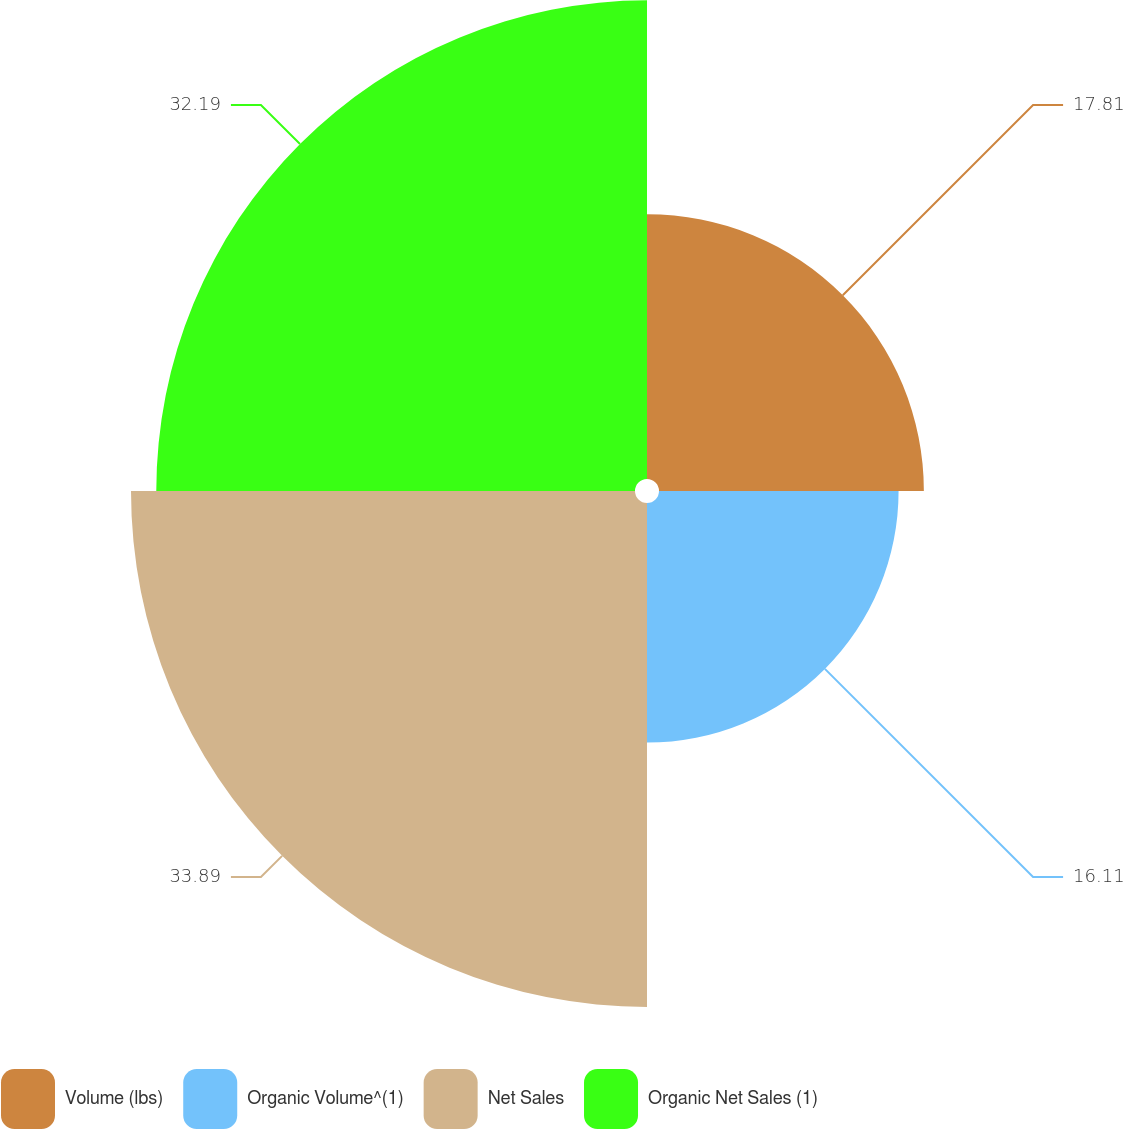Convert chart. <chart><loc_0><loc_0><loc_500><loc_500><pie_chart><fcel>Volume (lbs)<fcel>Organic Volume^(1)<fcel>Net Sales<fcel>Organic Net Sales (1)<nl><fcel>17.81%<fcel>16.11%<fcel>33.89%<fcel>32.19%<nl></chart> 